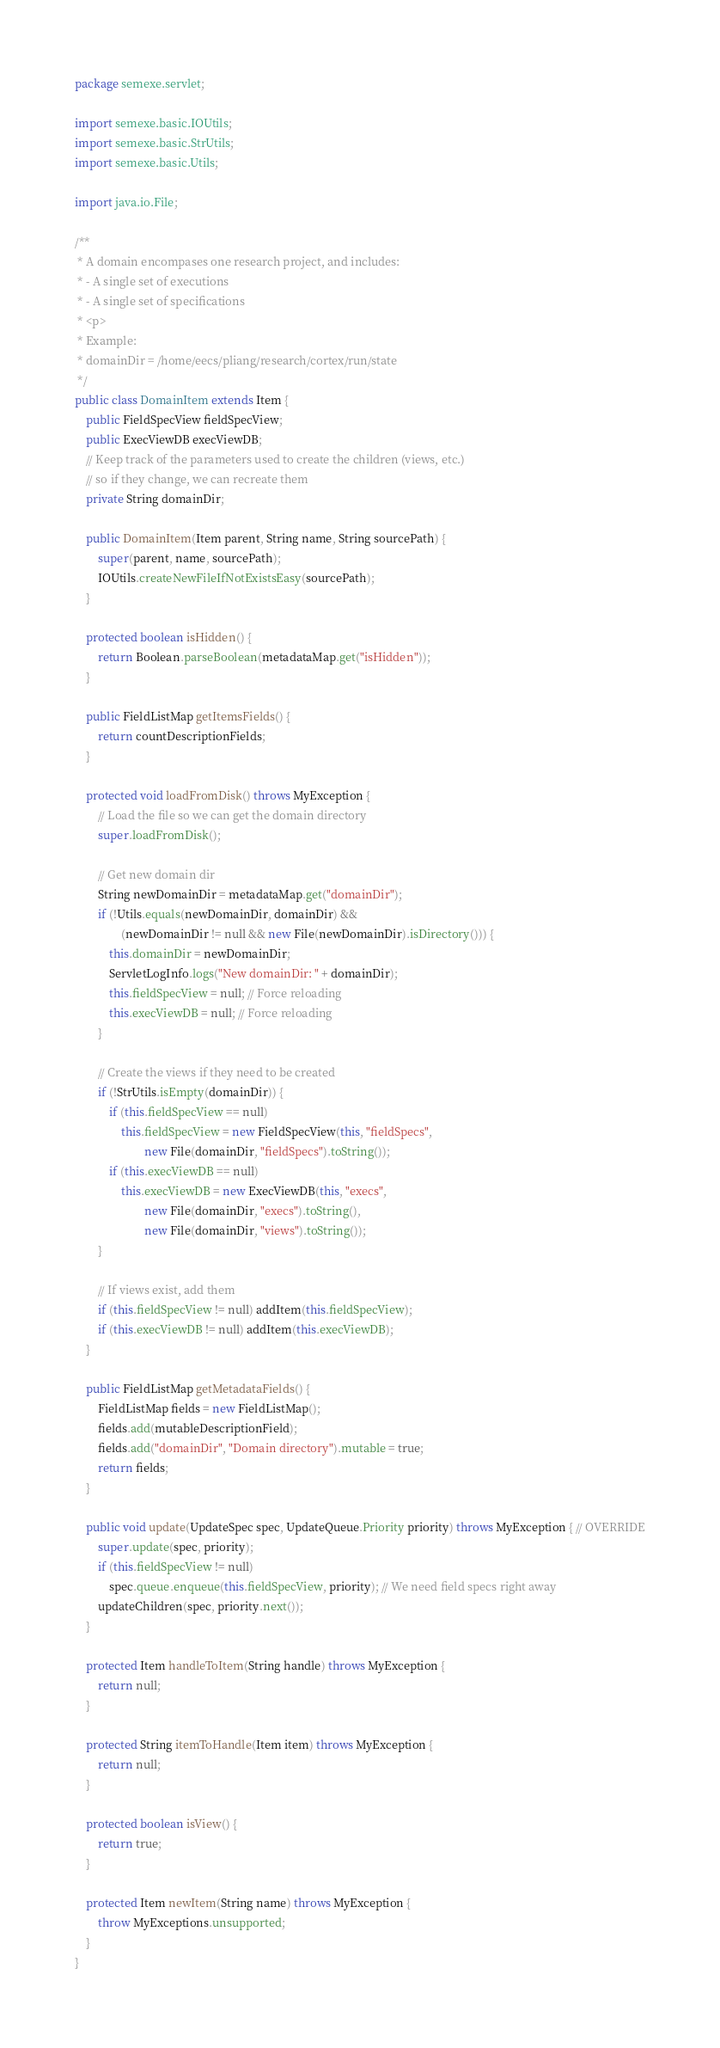Convert code to text. <code><loc_0><loc_0><loc_500><loc_500><_Java_>package semexe.servlet;

import semexe.basic.IOUtils;
import semexe.basic.StrUtils;
import semexe.basic.Utils;

import java.io.File;

/**
 * A domain encompases one research project, and includes:
 * - A single set of executions
 * - A single set of specifications
 * <p>
 * Example:
 * domainDir = /home/eecs/pliang/research/cortex/run/state
 */
public class DomainItem extends Item {
    public FieldSpecView fieldSpecView;
    public ExecViewDB execViewDB;
    // Keep track of the parameters used to create the children (views, etc.)
    // so if they change, we can recreate them
    private String domainDir;

    public DomainItem(Item parent, String name, String sourcePath) {
        super(parent, name, sourcePath);
        IOUtils.createNewFileIfNotExistsEasy(sourcePath);
    }

    protected boolean isHidden() {
        return Boolean.parseBoolean(metadataMap.get("isHidden"));
    }

    public FieldListMap getItemsFields() {
        return countDescriptionFields;
    }

    protected void loadFromDisk() throws MyException {
        // Load the file so we can get the domain directory
        super.loadFromDisk();

        // Get new domain dir
        String newDomainDir = metadataMap.get("domainDir");
        if (!Utils.equals(newDomainDir, domainDir) &&
                (newDomainDir != null && new File(newDomainDir).isDirectory())) {
            this.domainDir = newDomainDir;
            ServletLogInfo.logs("New domainDir: " + domainDir);
            this.fieldSpecView = null; // Force reloading
            this.execViewDB = null; // Force reloading
        }

        // Create the views if they need to be created
        if (!StrUtils.isEmpty(domainDir)) {
            if (this.fieldSpecView == null)
                this.fieldSpecView = new FieldSpecView(this, "fieldSpecs",
                        new File(domainDir, "fieldSpecs").toString());
            if (this.execViewDB == null)
                this.execViewDB = new ExecViewDB(this, "execs",
                        new File(domainDir, "execs").toString(),
                        new File(domainDir, "views").toString());
        }

        // If views exist, add them
        if (this.fieldSpecView != null) addItem(this.fieldSpecView);
        if (this.execViewDB != null) addItem(this.execViewDB);
    }

    public FieldListMap getMetadataFields() {
        FieldListMap fields = new FieldListMap();
        fields.add(mutableDescriptionField);
        fields.add("domainDir", "Domain directory").mutable = true;
        return fields;
    }

    public void update(UpdateSpec spec, UpdateQueue.Priority priority) throws MyException { // OVERRIDE
        super.update(spec, priority);
        if (this.fieldSpecView != null)
            spec.queue.enqueue(this.fieldSpecView, priority); // We need field specs right away
        updateChildren(spec, priority.next());
    }

    protected Item handleToItem(String handle) throws MyException {
        return null;
    }

    protected String itemToHandle(Item item) throws MyException {
        return null;
    }

    protected boolean isView() {
        return true;
    }

    protected Item newItem(String name) throws MyException {
        throw MyExceptions.unsupported;
    }
}
</code> 